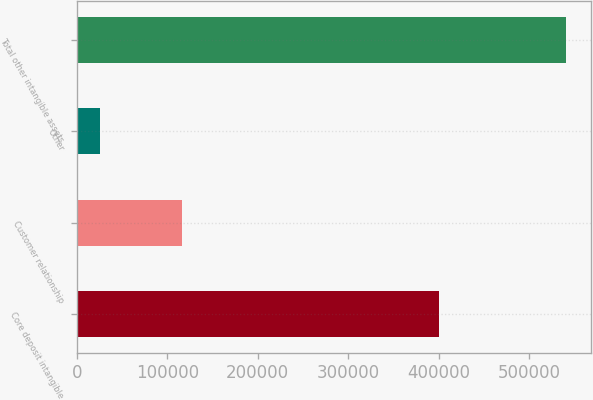Convert chart. <chart><loc_0><loc_0><loc_500><loc_500><bar_chart><fcel>Core deposit intangible<fcel>Customer relationship<fcel>Other<fcel>Total other intangible assets<nl><fcel>400058<fcel>116094<fcel>25164<fcel>541316<nl></chart> 